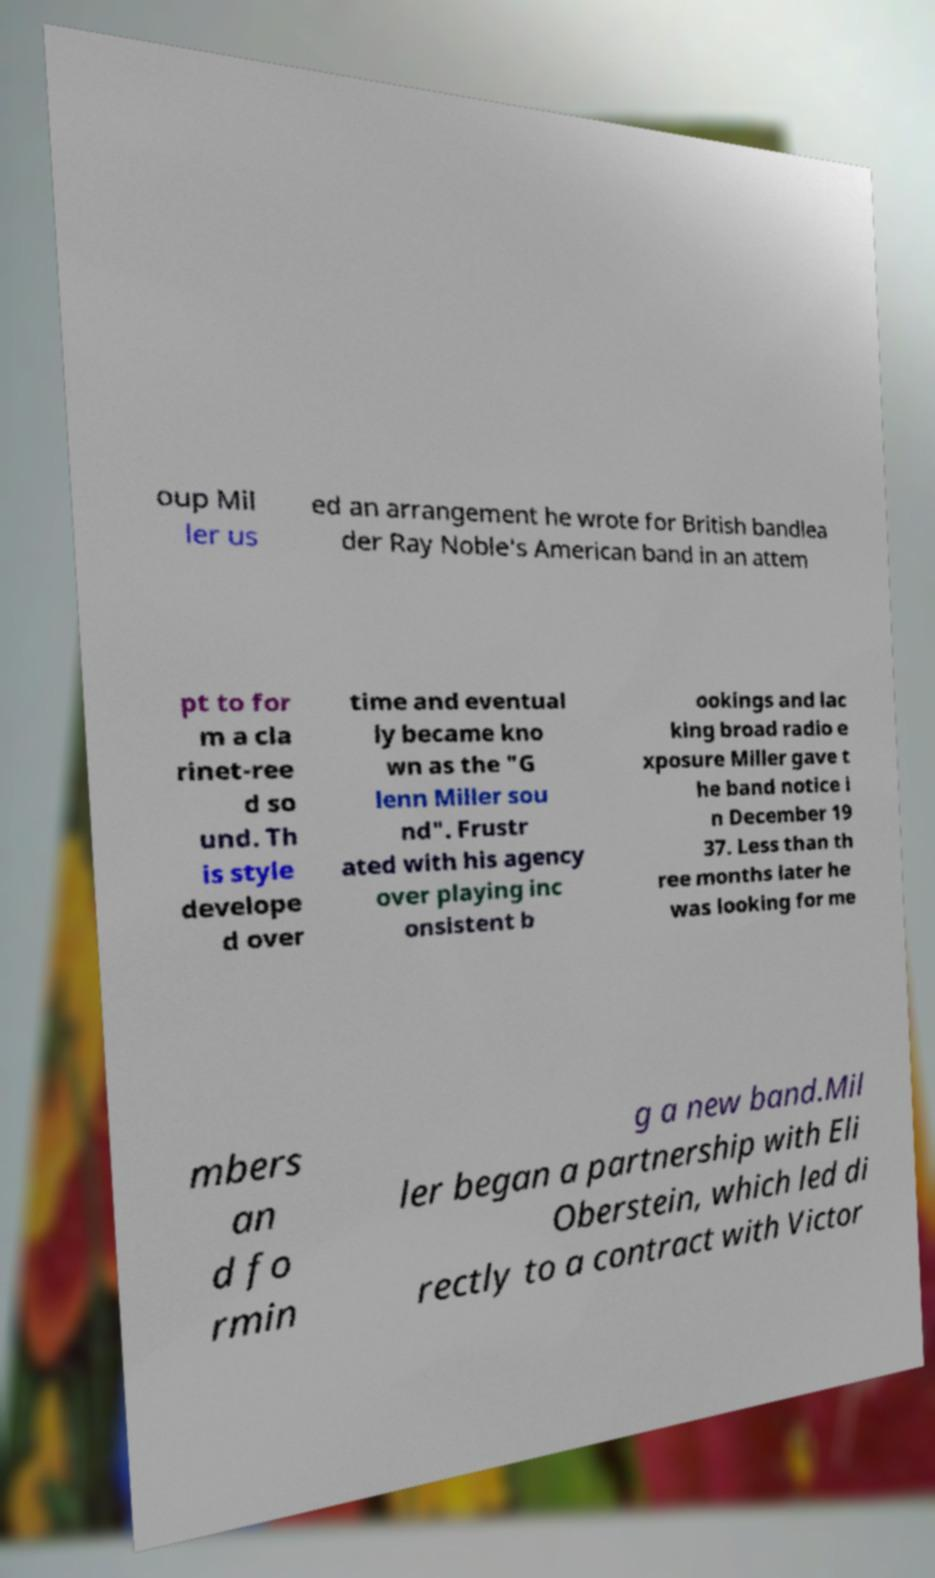What messages or text are displayed in this image? I need them in a readable, typed format. oup Mil ler us ed an arrangement he wrote for British bandlea der Ray Noble's American band in an attem pt to for m a cla rinet-ree d so und. Th is style develope d over time and eventual ly became kno wn as the "G lenn Miller sou nd". Frustr ated with his agency over playing inc onsistent b ookings and lac king broad radio e xposure Miller gave t he band notice i n December 19 37. Less than th ree months later he was looking for me mbers an d fo rmin g a new band.Mil ler began a partnership with Eli Oberstein, which led di rectly to a contract with Victor 